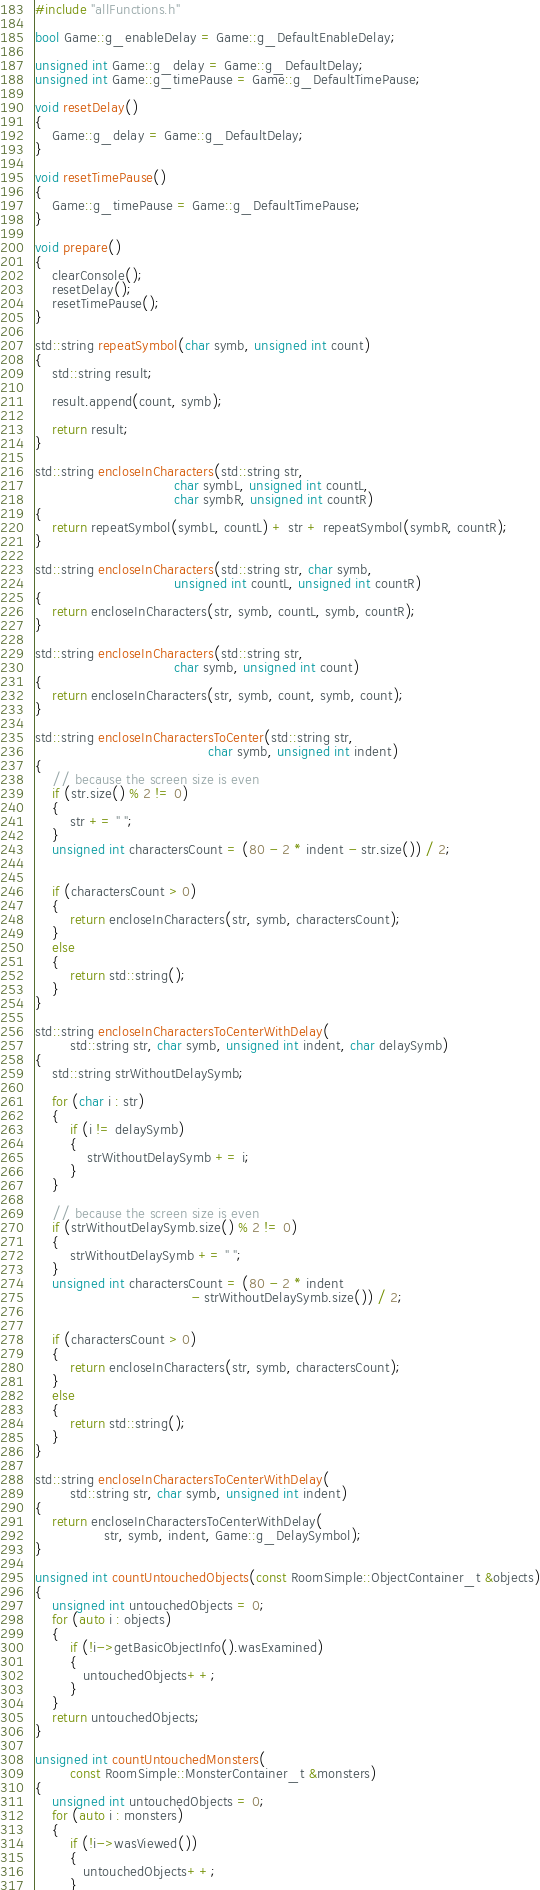Convert code to text. <code><loc_0><loc_0><loc_500><loc_500><_C++_>#include "allFunctions.h"

bool Game::g_enableDelay = Game::g_DefaultEnableDelay;

unsigned int Game::g_delay = Game::g_DefaultDelay;
unsigned int Game::g_timePause = Game::g_DefaultTimePause;

void resetDelay()
{
    Game::g_delay = Game::g_DefaultDelay;
}

void resetTimePause()
{
    Game::g_timePause = Game::g_DefaultTimePause;
}

void prepare()
{
    clearConsole();
    resetDelay();
    resetTimePause();
}

std::string repeatSymbol(char symb, unsigned int count)
{
    std::string result;
    
    result.append(count, symb);
    
    return result;
}

std::string encloseInCharacters(std::string str,
                                char symbL, unsigned int countL,
                                char symbR, unsigned int countR)
{
    return repeatSymbol(symbL, countL) + str + repeatSymbol(symbR, countR);
}

std::string encloseInCharacters(std::string str, char symb,
                                unsigned int countL, unsigned int countR)
{
    return encloseInCharacters(str, symb, countL, symb, countR);
}

std::string encloseInCharacters(std::string str,
                                char symb, unsigned int count)
{
    return encloseInCharacters(str, symb, count, symb, count);
}

std::string encloseInCharactersToCenter(std::string str,
                                        char symb, unsigned int indent)
{
    // because the screen size is even
    if (str.size() % 2 != 0)
    {
        str += " ";
    }
    unsigned int charactersCount = (80 - 2 * indent - str.size()) / 2;

    
    if (charactersCount > 0)
    {
        return encloseInCharacters(str, symb, charactersCount);
    }
    else
    {
        return std::string();
    }
}

std::string encloseInCharactersToCenterWithDelay(
        std::string str, char symb, unsigned int indent, char delaySymb)
{
    std::string strWithoutDelaySymb;
    
    for (char i : str)
    {
        if (i != delaySymb)
        {
            strWithoutDelaySymb += i;
        }
    }
    
    // because the screen size is even
    if (strWithoutDelaySymb.size() % 2 != 0)
    {
        strWithoutDelaySymb += " ";
    }
    unsigned int charactersCount = (80 - 2 * indent
                                    - strWithoutDelaySymb.size()) / 2;

    
    if (charactersCount > 0)
    {
        return encloseInCharacters(str, symb, charactersCount);
    }
    else
    {
        return std::string();
    }
}

std::string encloseInCharactersToCenterWithDelay(
        std::string str, char symb, unsigned int indent)
{
    return encloseInCharactersToCenterWithDelay(
                str, symb, indent, Game::g_DelaySymbol);
}

unsigned int countUntouchedObjects(const RoomSimple::ObjectContainer_t &objects)
{
    unsigned int untouchedObjects = 0;
    for (auto i : objects)
    {
        if (!i->getBasicObjectInfo().wasExamined)
        {
           untouchedObjects++;
        }
    }
    return untouchedObjects;
}

unsigned int countUntouchedMonsters(
        const RoomSimple::MonsterContainer_t &monsters)
{
    unsigned int untouchedObjects = 0;
    for (auto i : monsters)
    {
        if (!i->wasViewed())
        {
           untouchedObjects++;
        }</code> 